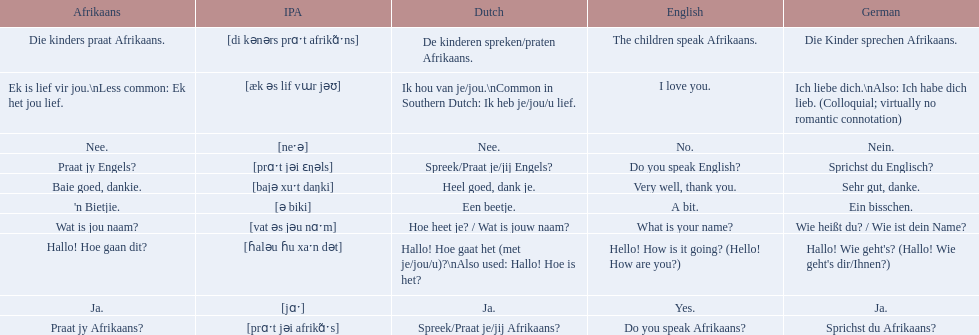How do you say do you speak english in german? Sprichst du Englisch?. What about do you speak afrikaanss? in afrikaans? Praat jy Afrikaans?. 